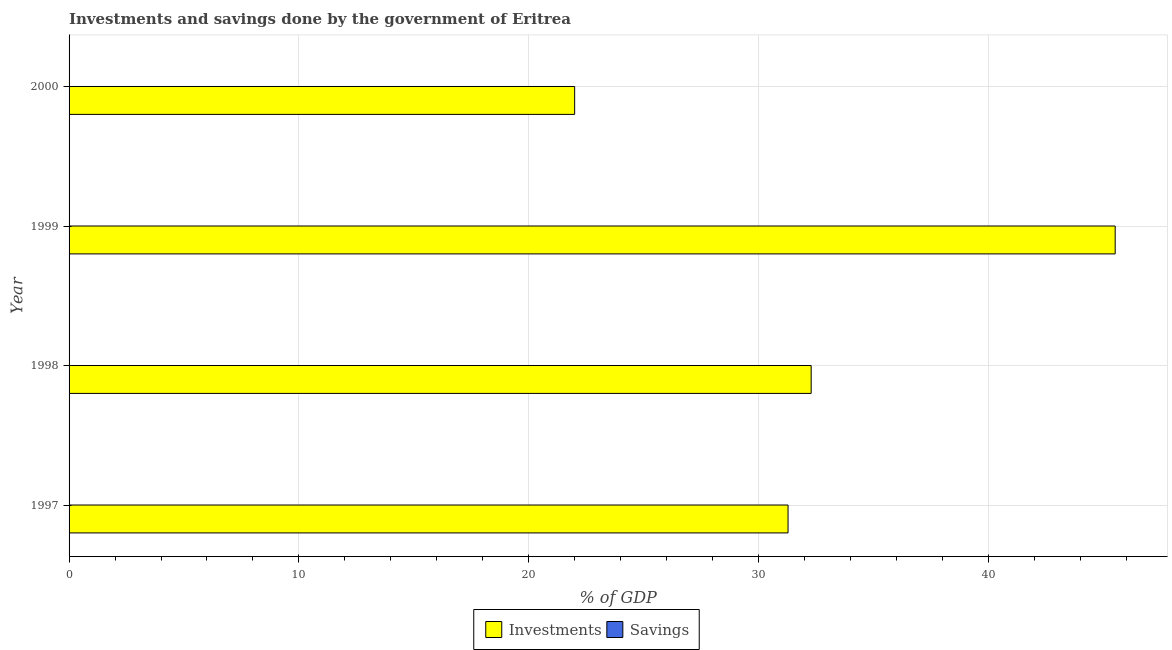How many different coloured bars are there?
Offer a terse response. 1. Are the number of bars on each tick of the Y-axis equal?
Provide a succinct answer. Yes. How many bars are there on the 1st tick from the bottom?
Your answer should be compact. 1. What is the label of the 4th group of bars from the top?
Provide a short and direct response. 1997. In how many cases, is the number of bars for a given year not equal to the number of legend labels?
Offer a terse response. 4. Across all years, what is the maximum investments of government?
Your response must be concise. 45.51. Across all years, what is the minimum investments of government?
Your answer should be compact. 22. In which year was the investments of government maximum?
Give a very brief answer. 1999. What is the total savings of government in the graph?
Give a very brief answer. 0. What is the difference between the investments of government in 1997 and that in 1999?
Ensure brevity in your answer.  -14.23. What is the difference between the investments of government in 1997 and the savings of government in 1999?
Make the answer very short. 31.28. What is the average investments of government per year?
Your answer should be very brief. 32.77. In how many years, is the investments of government greater than 42 %?
Make the answer very short. 1. What is the ratio of the investments of government in 1997 to that in 1999?
Your response must be concise. 0.69. Is the investments of government in 1998 less than that in 2000?
Make the answer very short. No. What is the difference between the highest and the second highest investments of government?
Ensure brevity in your answer.  13.23. What is the difference between the highest and the lowest investments of government?
Ensure brevity in your answer.  23.52. In how many years, is the investments of government greater than the average investments of government taken over all years?
Your response must be concise. 1. How many years are there in the graph?
Provide a succinct answer. 4. Are the values on the major ticks of X-axis written in scientific E-notation?
Offer a terse response. No. Does the graph contain any zero values?
Give a very brief answer. Yes. Does the graph contain grids?
Provide a short and direct response. Yes. What is the title of the graph?
Provide a succinct answer. Investments and savings done by the government of Eritrea. What is the label or title of the X-axis?
Your answer should be compact. % of GDP. What is the % of GDP of Investments in 1997?
Make the answer very short. 31.28. What is the % of GDP of Investments in 1998?
Your response must be concise. 32.29. What is the % of GDP in Investments in 1999?
Provide a succinct answer. 45.51. What is the % of GDP in Savings in 1999?
Your response must be concise. 0. What is the % of GDP of Investments in 2000?
Keep it short and to the point. 22. What is the % of GDP of Savings in 2000?
Keep it short and to the point. 0. Across all years, what is the maximum % of GDP of Investments?
Keep it short and to the point. 45.51. Across all years, what is the minimum % of GDP in Investments?
Ensure brevity in your answer.  22. What is the total % of GDP in Investments in the graph?
Your response must be concise. 131.08. What is the difference between the % of GDP of Investments in 1997 and that in 1998?
Offer a terse response. -1.01. What is the difference between the % of GDP in Investments in 1997 and that in 1999?
Your answer should be compact. -14.23. What is the difference between the % of GDP of Investments in 1997 and that in 2000?
Provide a short and direct response. 9.28. What is the difference between the % of GDP in Investments in 1998 and that in 1999?
Ensure brevity in your answer.  -13.23. What is the difference between the % of GDP of Investments in 1998 and that in 2000?
Provide a short and direct response. 10.29. What is the difference between the % of GDP of Investments in 1999 and that in 2000?
Give a very brief answer. 23.52. What is the average % of GDP in Investments per year?
Keep it short and to the point. 32.77. What is the average % of GDP in Savings per year?
Your answer should be compact. 0. What is the ratio of the % of GDP in Investments in 1997 to that in 1998?
Offer a terse response. 0.97. What is the ratio of the % of GDP of Investments in 1997 to that in 1999?
Provide a succinct answer. 0.69. What is the ratio of the % of GDP in Investments in 1997 to that in 2000?
Provide a short and direct response. 1.42. What is the ratio of the % of GDP in Investments in 1998 to that in 1999?
Keep it short and to the point. 0.71. What is the ratio of the % of GDP in Investments in 1998 to that in 2000?
Offer a terse response. 1.47. What is the ratio of the % of GDP of Investments in 1999 to that in 2000?
Give a very brief answer. 2.07. What is the difference between the highest and the second highest % of GDP in Investments?
Your answer should be very brief. 13.23. What is the difference between the highest and the lowest % of GDP in Investments?
Make the answer very short. 23.52. 